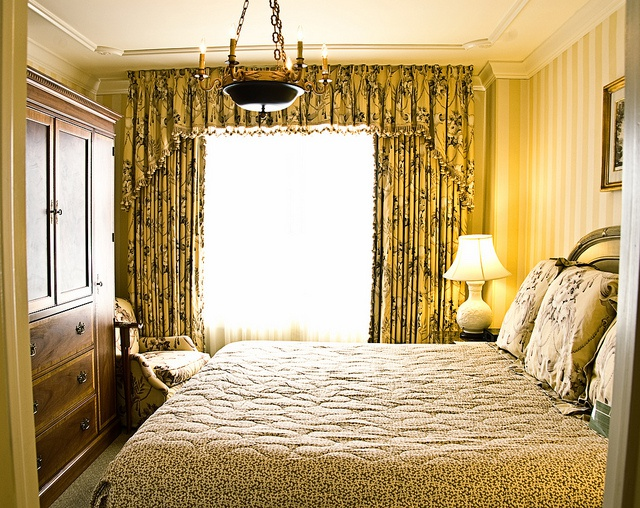Describe the objects in this image and their specific colors. I can see bed in olive, ivory, and tan tones and chair in olive, black, ivory, maroon, and tan tones in this image. 